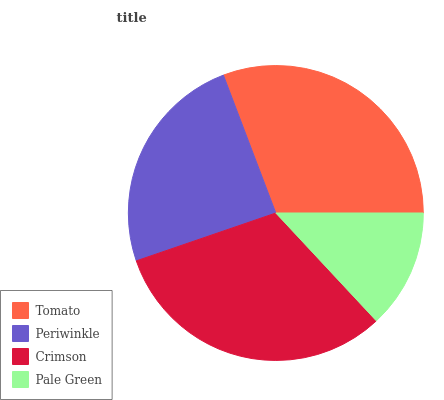Is Pale Green the minimum?
Answer yes or no. Yes. Is Crimson the maximum?
Answer yes or no. Yes. Is Periwinkle the minimum?
Answer yes or no. No. Is Periwinkle the maximum?
Answer yes or no. No. Is Tomato greater than Periwinkle?
Answer yes or no. Yes. Is Periwinkle less than Tomato?
Answer yes or no. Yes. Is Periwinkle greater than Tomato?
Answer yes or no. No. Is Tomato less than Periwinkle?
Answer yes or no. No. Is Tomato the high median?
Answer yes or no. Yes. Is Periwinkle the low median?
Answer yes or no. Yes. Is Pale Green the high median?
Answer yes or no. No. Is Pale Green the low median?
Answer yes or no. No. 